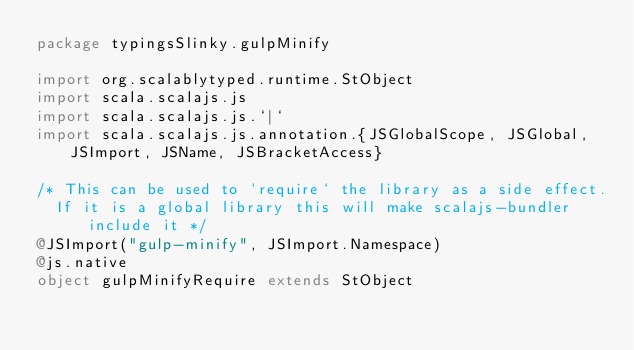<code> <loc_0><loc_0><loc_500><loc_500><_Scala_>package typingsSlinky.gulpMinify

import org.scalablytyped.runtime.StObject
import scala.scalajs.js
import scala.scalajs.js.`|`
import scala.scalajs.js.annotation.{JSGlobalScope, JSGlobal, JSImport, JSName, JSBracketAccess}

/* This can be used to `require` the library as a side effect.
  If it is a global library this will make scalajs-bundler include it */
@JSImport("gulp-minify", JSImport.Namespace)
@js.native
object gulpMinifyRequire extends StObject
</code> 